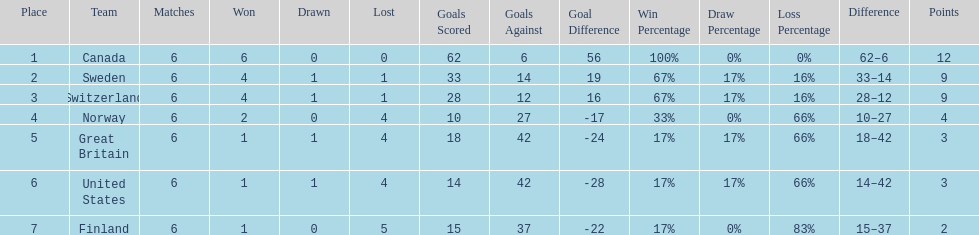Write the full table. {'header': ['Place', 'Team', 'Matches', 'Won', 'Drawn', 'Lost', 'Goals Scored', 'Goals Against', 'Goal Difference', 'Win Percentage', 'Draw Percentage', 'Loss Percentage', 'Difference', 'Points'], 'rows': [['1', 'Canada', '6', '6', '0', '0', '62', '6', '56', '100%', '0%', '0%', '62–6', '12'], ['2', 'Sweden', '6', '4', '1', '1', '33', '14', '19', '67%', '17%', '16%', '33–14', '9'], ['3', 'Switzerland', '6', '4', '1', '1', '28', '12', '16', '67%', '17%', '16%', '28–12', '9'], ['4', 'Norway', '6', '2', '0', '4', '10', '27', '-17', '33%', '0%', '66%', '10–27', '4'], ['5', 'Great Britain', '6', '1', '1', '4', '18', '42', '-24', '17%', '17%', '66%', '18–42', '3'], ['6', 'United States', '6', '1', '1', '4', '14', '42', '-28', '17%', '17%', '66%', '14–42', '3'], ['7', 'Finland', '6', '1', '0', '5', '15', '37', '-22', '17%', '0%', '83%', '15–37', '2']]} Which country's team came in last place during the 1951 world ice hockey championships? Finland. 